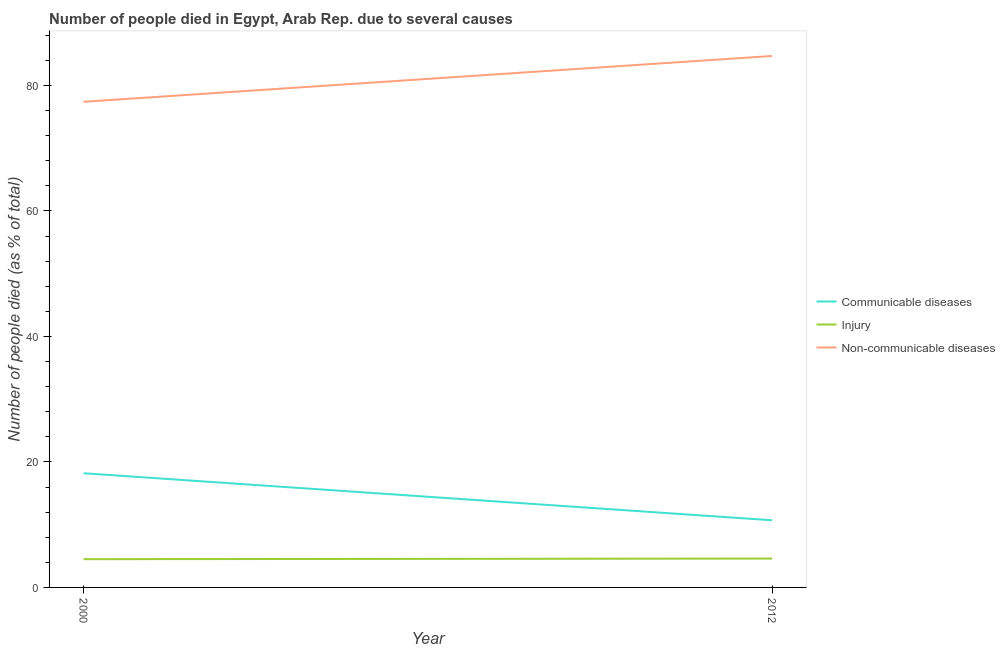How many different coloured lines are there?
Provide a succinct answer. 3. Is the number of lines equal to the number of legend labels?
Ensure brevity in your answer.  Yes. What is the number of people who dies of non-communicable diseases in 2000?
Your answer should be compact. 77.4. Across all years, what is the minimum number of people who died of communicable diseases?
Your response must be concise. 10.7. What is the total number of people who died of injury in the graph?
Provide a short and direct response. 9.1. What is the average number of people who dies of non-communicable diseases per year?
Offer a terse response. 81.05. In the year 2000, what is the difference between the number of people who died of communicable diseases and number of people who dies of non-communicable diseases?
Give a very brief answer. -59.2. What is the ratio of the number of people who died of injury in 2000 to that in 2012?
Offer a very short reply. 0.98. Is the number of people who died of injury in 2000 less than that in 2012?
Keep it short and to the point. Yes. In how many years, is the number of people who died of injury greater than the average number of people who died of injury taken over all years?
Offer a terse response. 1. Is it the case that in every year, the sum of the number of people who died of communicable diseases and number of people who died of injury is greater than the number of people who dies of non-communicable diseases?
Your response must be concise. No. Is the number of people who dies of non-communicable diseases strictly greater than the number of people who died of injury over the years?
Make the answer very short. Yes. Is the number of people who died of communicable diseases strictly less than the number of people who dies of non-communicable diseases over the years?
Provide a short and direct response. Yes. What is the difference between two consecutive major ticks on the Y-axis?
Provide a short and direct response. 20. Does the graph contain any zero values?
Your response must be concise. No. Does the graph contain grids?
Give a very brief answer. No. How are the legend labels stacked?
Your answer should be very brief. Vertical. What is the title of the graph?
Make the answer very short. Number of people died in Egypt, Arab Rep. due to several causes. Does "Non-communicable diseases" appear as one of the legend labels in the graph?
Your answer should be very brief. Yes. What is the label or title of the X-axis?
Give a very brief answer. Year. What is the label or title of the Y-axis?
Provide a short and direct response. Number of people died (as % of total). What is the Number of people died (as % of total) of Communicable diseases in 2000?
Your answer should be very brief. 18.2. What is the Number of people died (as % of total) in Non-communicable diseases in 2000?
Offer a terse response. 77.4. What is the Number of people died (as % of total) in Communicable diseases in 2012?
Provide a succinct answer. 10.7. What is the Number of people died (as % of total) of Non-communicable diseases in 2012?
Your answer should be compact. 84.7. Across all years, what is the maximum Number of people died (as % of total) of Non-communicable diseases?
Offer a very short reply. 84.7. Across all years, what is the minimum Number of people died (as % of total) in Non-communicable diseases?
Provide a short and direct response. 77.4. What is the total Number of people died (as % of total) of Communicable diseases in the graph?
Your response must be concise. 28.9. What is the total Number of people died (as % of total) of Injury in the graph?
Provide a short and direct response. 9.1. What is the total Number of people died (as % of total) of Non-communicable diseases in the graph?
Your response must be concise. 162.1. What is the difference between the Number of people died (as % of total) of Injury in 2000 and that in 2012?
Give a very brief answer. -0.1. What is the difference between the Number of people died (as % of total) of Communicable diseases in 2000 and the Number of people died (as % of total) of Non-communicable diseases in 2012?
Provide a succinct answer. -66.5. What is the difference between the Number of people died (as % of total) in Injury in 2000 and the Number of people died (as % of total) in Non-communicable diseases in 2012?
Provide a succinct answer. -80.2. What is the average Number of people died (as % of total) in Communicable diseases per year?
Provide a short and direct response. 14.45. What is the average Number of people died (as % of total) of Injury per year?
Provide a succinct answer. 4.55. What is the average Number of people died (as % of total) in Non-communicable diseases per year?
Give a very brief answer. 81.05. In the year 2000, what is the difference between the Number of people died (as % of total) in Communicable diseases and Number of people died (as % of total) in Non-communicable diseases?
Give a very brief answer. -59.2. In the year 2000, what is the difference between the Number of people died (as % of total) of Injury and Number of people died (as % of total) of Non-communicable diseases?
Offer a very short reply. -72.9. In the year 2012, what is the difference between the Number of people died (as % of total) of Communicable diseases and Number of people died (as % of total) of Injury?
Give a very brief answer. 6.1. In the year 2012, what is the difference between the Number of people died (as % of total) of Communicable diseases and Number of people died (as % of total) of Non-communicable diseases?
Provide a short and direct response. -74. In the year 2012, what is the difference between the Number of people died (as % of total) of Injury and Number of people died (as % of total) of Non-communicable diseases?
Offer a terse response. -80.1. What is the ratio of the Number of people died (as % of total) of Communicable diseases in 2000 to that in 2012?
Your response must be concise. 1.7. What is the ratio of the Number of people died (as % of total) of Injury in 2000 to that in 2012?
Your answer should be very brief. 0.98. What is the ratio of the Number of people died (as % of total) in Non-communicable diseases in 2000 to that in 2012?
Your response must be concise. 0.91. What is the difference between the highest and the second highest Number of people died (as % of total) in Communicable diseases?
Give a very brief answer. 7.5. What is the difference between the highest and the second highest Number of people died (as % of total) in Injury?
Your response must be concise. 0.1. What is the difference between the highest and the second highest Number of people died (as % of total) in Non-communicable diseases?
Give a very brief answer. 7.3. What is the difference between the highest and the lowest Number of people died (as % of total) of Injury?
Ensure brevity in your answer.  0.1. 